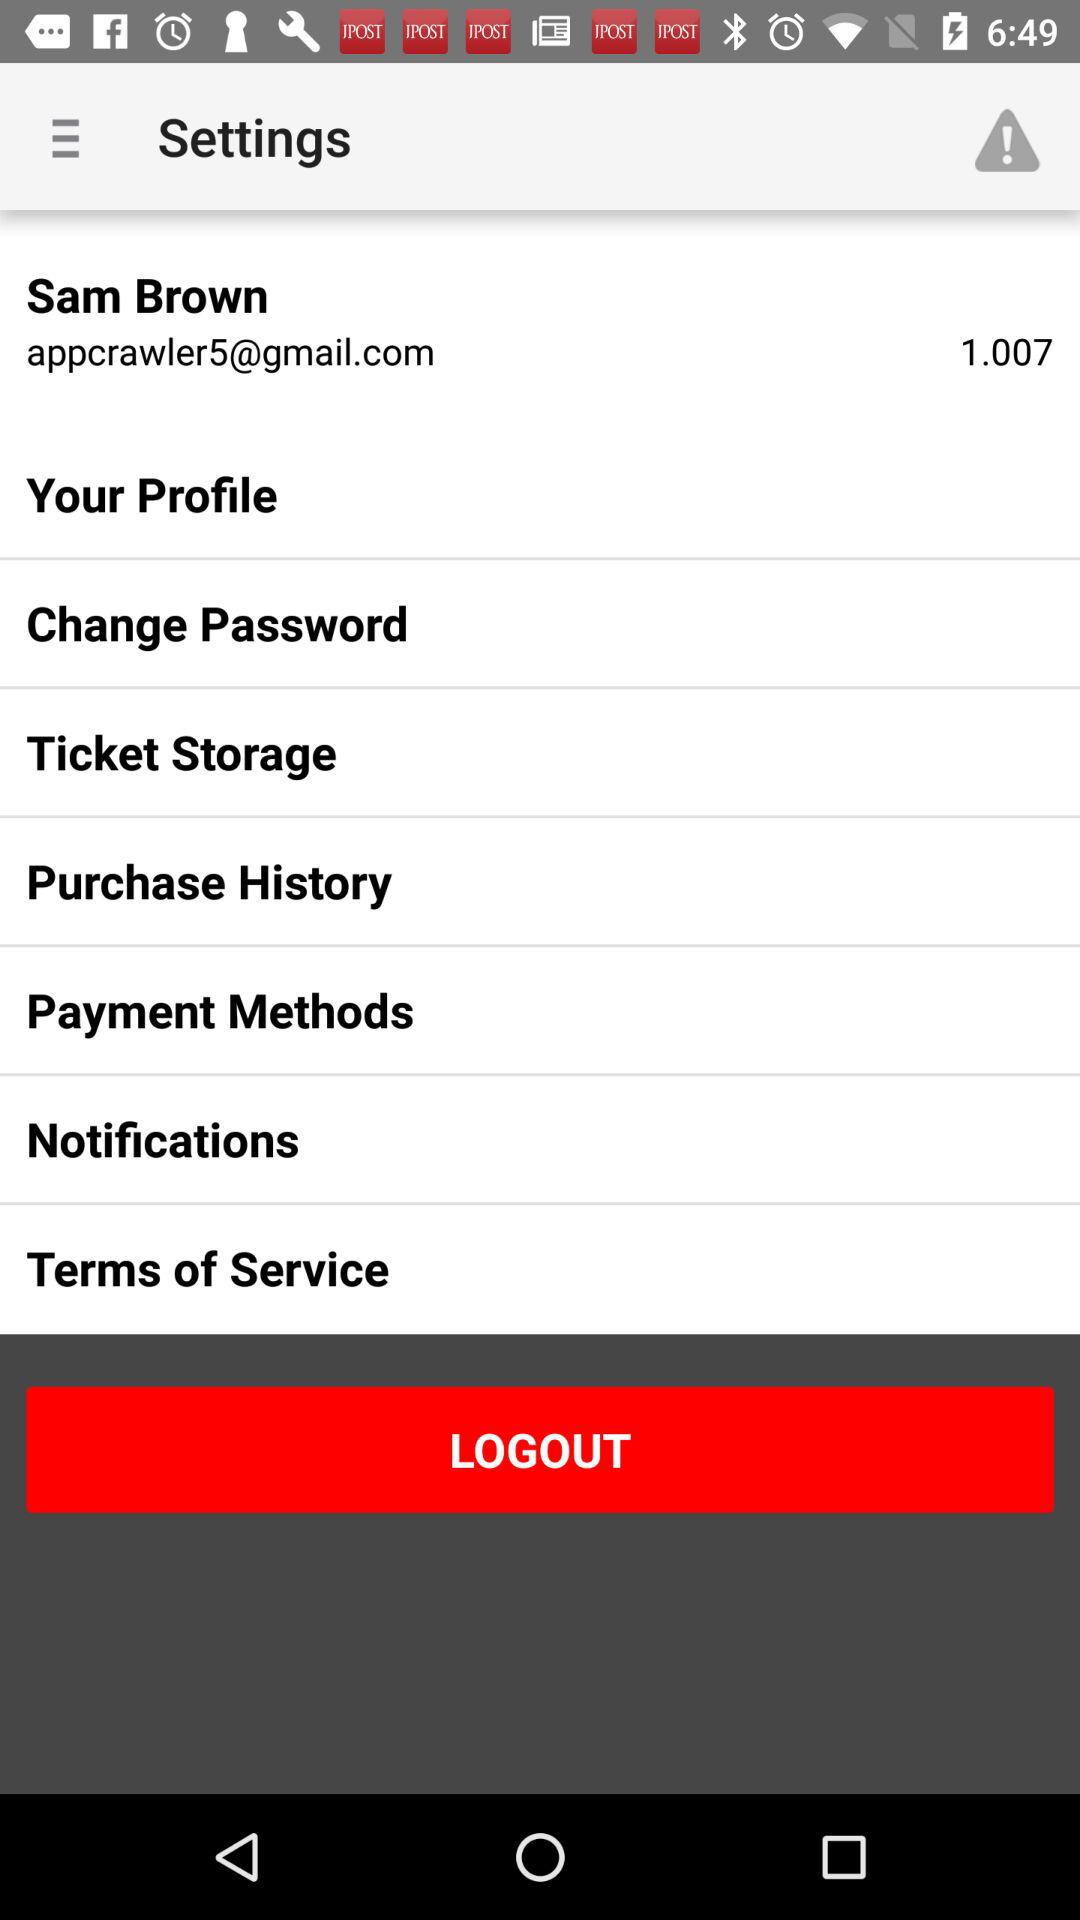Which Gmail address is used? The used Gmail address is appcrawler5@gmail.com. 